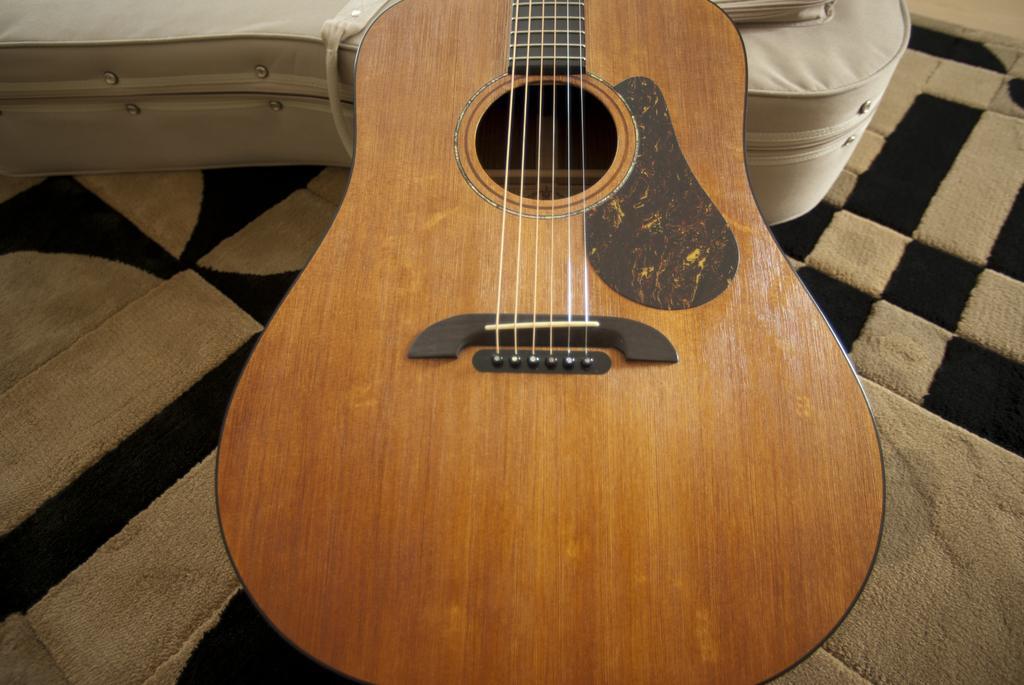Could you give a brief overview of what you see in this image? As we can see in the image there is a bed and guitar. 